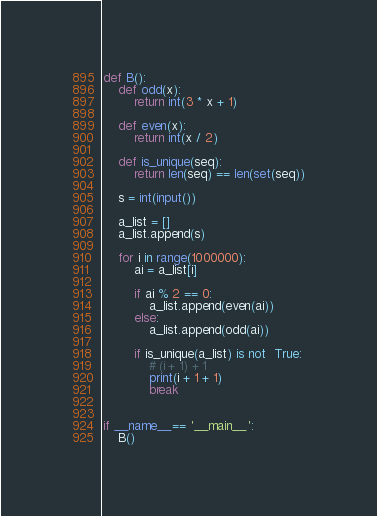<code> <loc_0><loc_0><loc_500><loc_500><_Python_>
def B():
    def odd(x):
        return int(3 * x + 1)
    
    def even(x):
        return int(x / 2)

    def is_unique(seq):
        return len(seq) == len(set(seq))

    s = int(input())

    a_list = []
    a_list.append(s)
    
    for i in range(1000000):
        ai = a_list[i]

        if ai % 2 == 0:
            a_list.append(even(ai))
        else:
            a_list.append(odd(ai))

        if is_unique(a_list) is not  True:
            # (i + 1) + 1
            print(i + 1 + 1)
            break
    

if __name__== '__main__':
    B()
</code> 